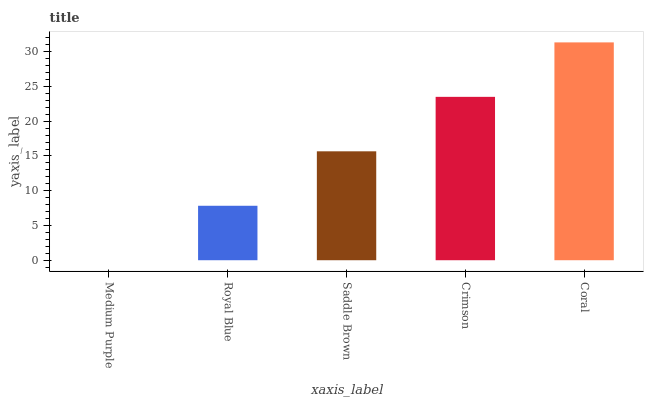Is Medium Purple the minimum?
Answer yes or no. Yes. Is Coral the maximum?
Answer yes or no. Yes. Is Royal Blue the minimum?
Answer yes or no. No. Is Royal Blue the maximum?
Answer yes or no. No. Is Royal Blue greater than Medium Purple?
Answer yes or no. Yes. Is Medium Purple less than Royal Blue?
Answer yes or no. Yes. Is Medium Purple greater than Royal Blue?
Answer yes or no. No. Is Royal Blue less than Medium Purple?
Answer yes or no. No. Is Saddle Brown the high median?
Answer yes or no. Yes. Is Saddle Brown the low median?
Answer yes or no. Yes. Is Royal Blue the high median?
Answer yes or no. No. Is Royal Blue the low median?
Answer yes or no. No. 